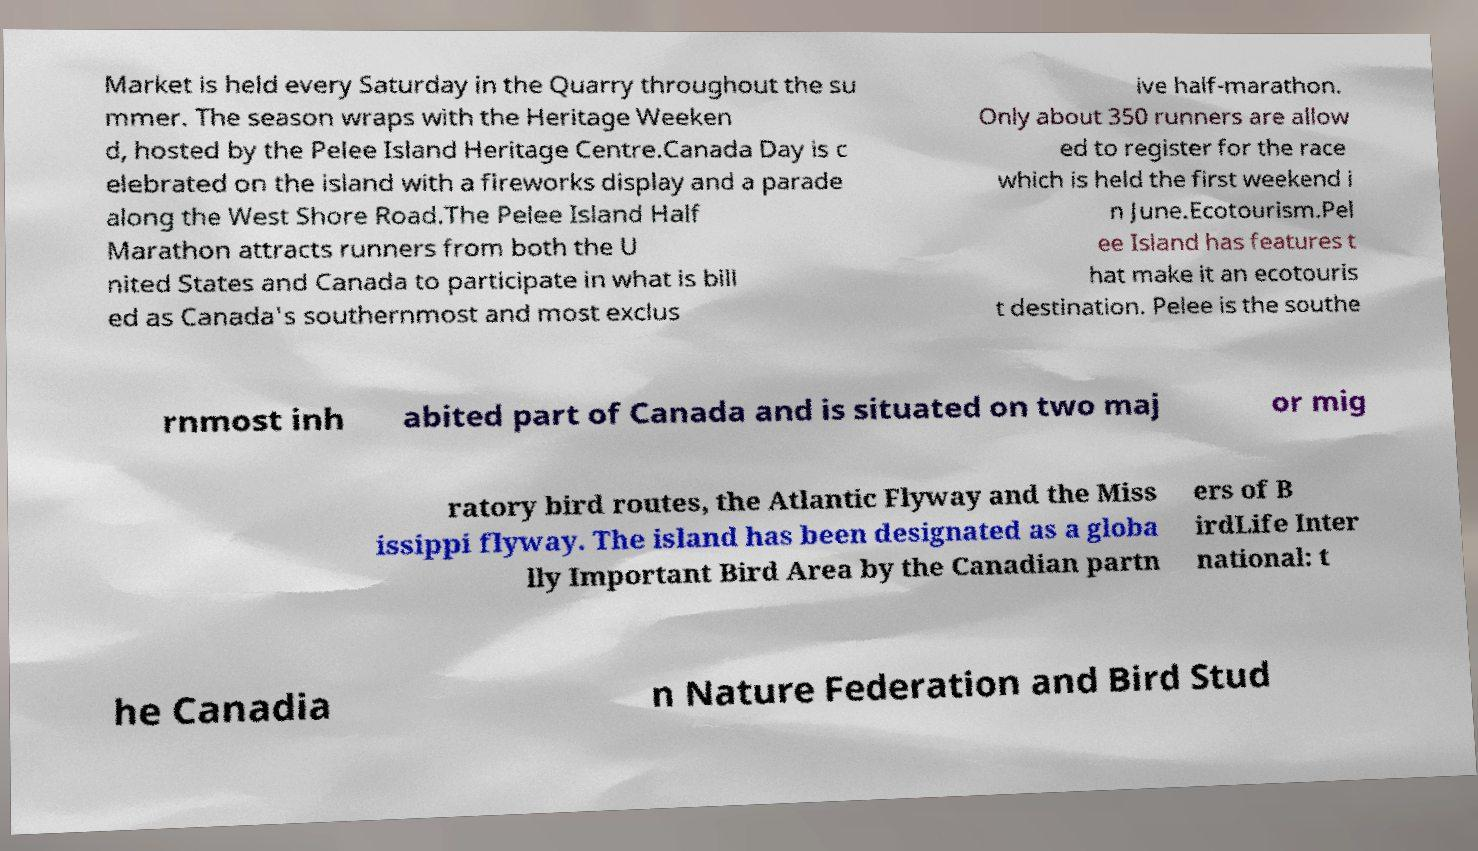I need the written content from this picture converted into text. Can you do that? Market is held every Saturday in the Quarry throughout the su mmer. The season wraps with the Heritage Weeken d, hosted by the Pelee Island Heritage Centre.Canada Day is c elebrated on the island with a fireworks display and a parade along the West Shore Road.The Pelee Island Half Marathon attracts runners from both the U nited States and Canada to participate in what is bill ed as Canada's southernmost and most exclus ive half-marathon. Only about 350 runners are allow ed to register for the race which is held the first weekend i n June.Ecotourism.Pel ee Island has features t hat make it an ecotouris t destination. Pelee is the southe rnmost inh abited part of Canada and is situated on two maj or mig ratory bird routes, the Atlantic Flyway and the Miss issippi flyway. The island has been designated as a globa lly Important Bird Area by the Canadian partn ers of B irdLife Inter national: t he Canadia n Nature Federation and Bird Stud 